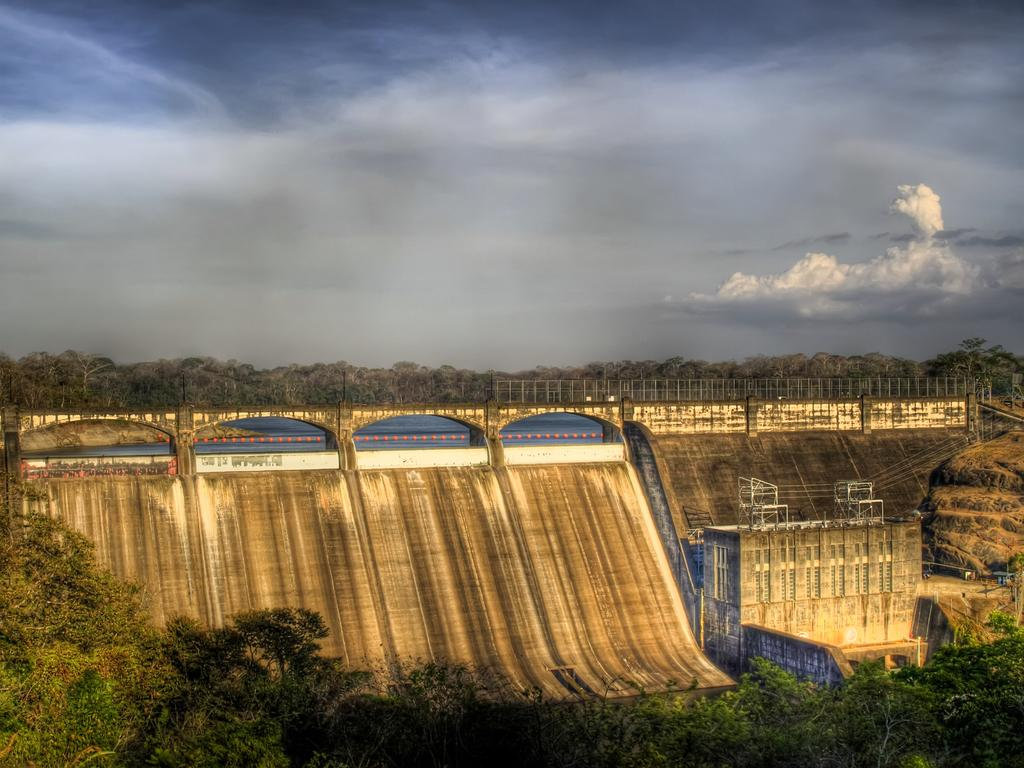What is the main structure in the middle of the image? There is a bridge at the center of the image. What is located in front of the bridge? There is a building in front of the bridge. What can be seen in the background of the image? There are trees, water, and the sky visible in the background of the image. How many kittens are playing on the bridge in the image? There are no kittens present in the image, so it is not possible to determine the number of kittens playing on the bridge. 